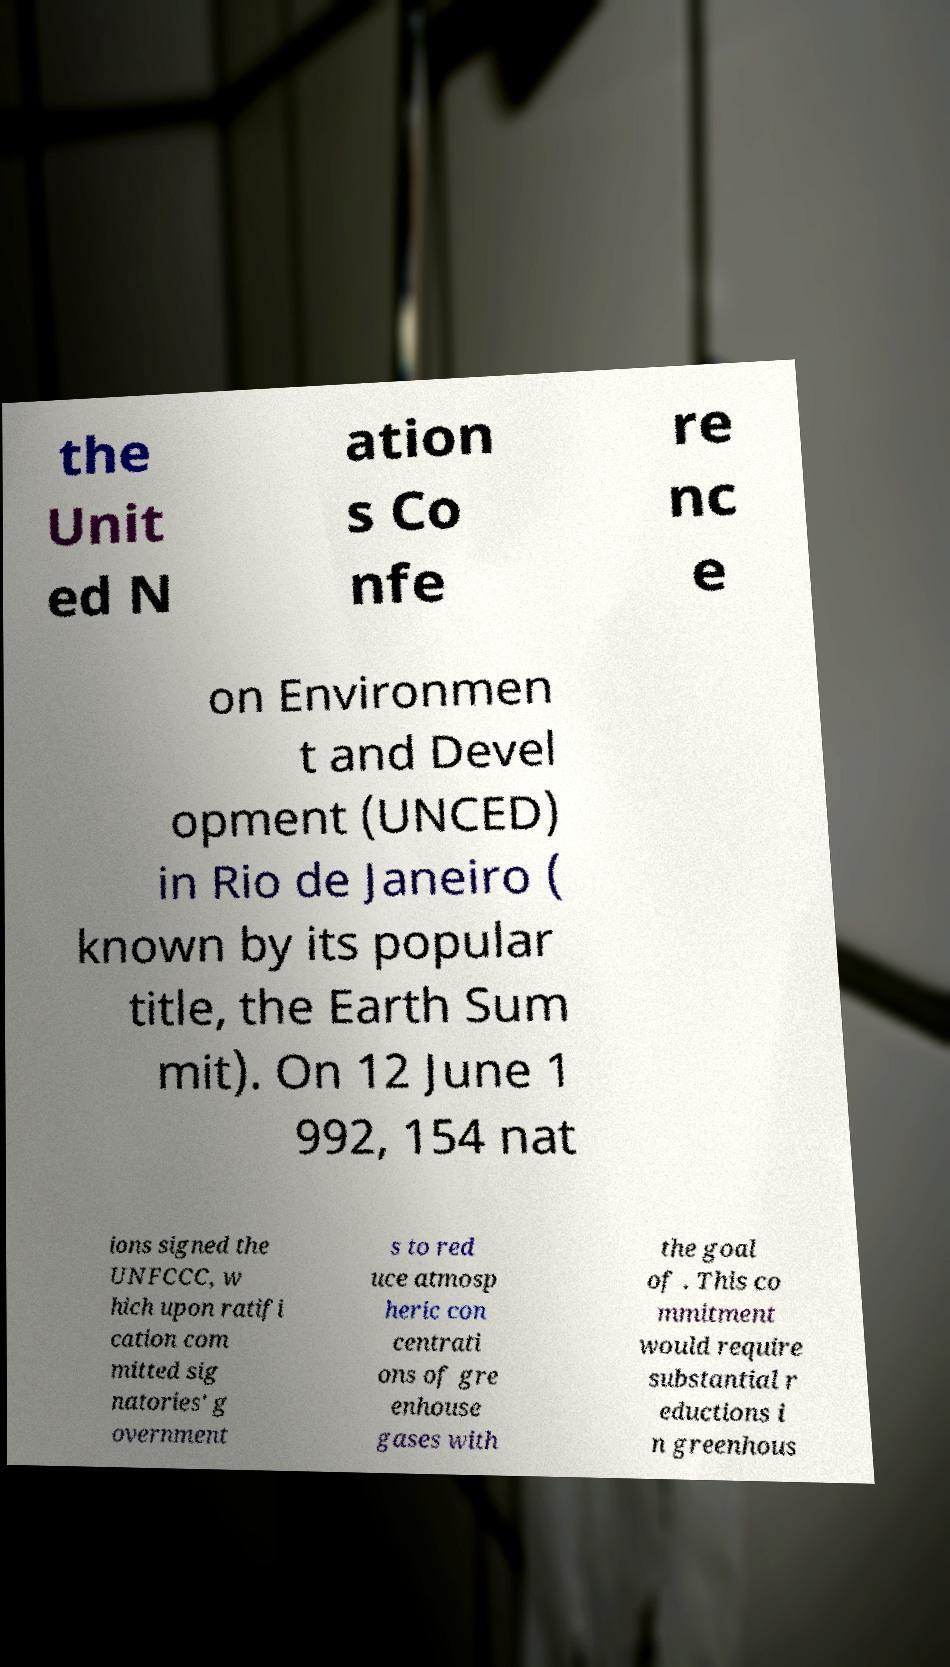For documentation purposes, I need the text within this image transcribed. Could you provide that? the Unit ed N ation s Co nfe re nc e on Environmen t and Devel opment (UNCED) in Rio de Janeiro ( known by its popular title, the Earth Sum mit). On 12 June 1 992, 154 nat ions signed the UNFCCC, w hich upon ratifi cation com mitted sig natories' g overnment s to red uce atmosp heric con centrati ons of gre enhouse gases with the goal of . This co mmitment would require substantial r eductions i n greenhous 